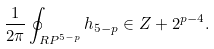Convert formula to latex. <formula><loc_0><loc_0><loc_500><loc_500>\frac { 1 } { 2 \pi } \oint _ { { R P } ^ { 5 - p } } h _ { 5 - p } \in { Z } + 2 ^ { p - 4 } .</formula> 